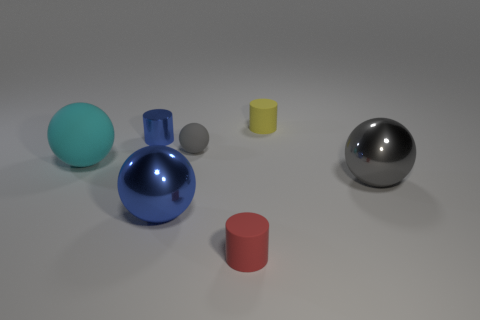Subtract all gray spheres. How many were subtracted if there are1gray spheres left? 1 Add 2 blue metal cylinders. How many objects exist? 9 Subtract all balls. How many objects are left? 3 Add 1 tiny cylinders. How many tiny cylinders are left? 4 Add 4 large rubber cubes. How many large rubber cubes exist? 4 Subtract 0 brown cylinders. How many objects are left? 7 Subtract all gray objects. Subtract all large gray objects. How many objects are left? 4 